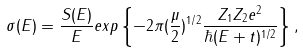<formula> <loc_0><loc_0><loc_500><loc_500>\sigma ( E ) = \frac { S ( E ) } { E } e x p \left \{ - 2 \pi ( \frac { \mu } { 2 } ) ^ { 1 / 2 } \frac { Z _ { 1 } Z _ { 2 } e ^ { 2 } } { \hbar { ( } E + t ) ^ { 1 / 2 } } \right \} ,</formula> 